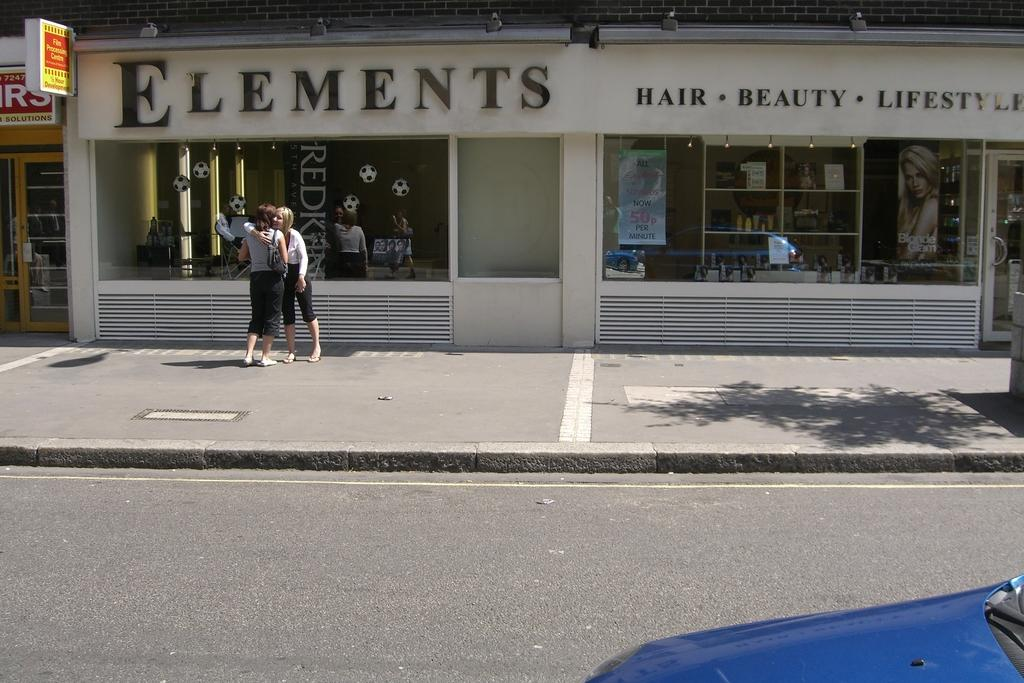<image>
Relay a brief, clear account of the picture shown. Both hair and beauty appointments can be gotten in this salon. 